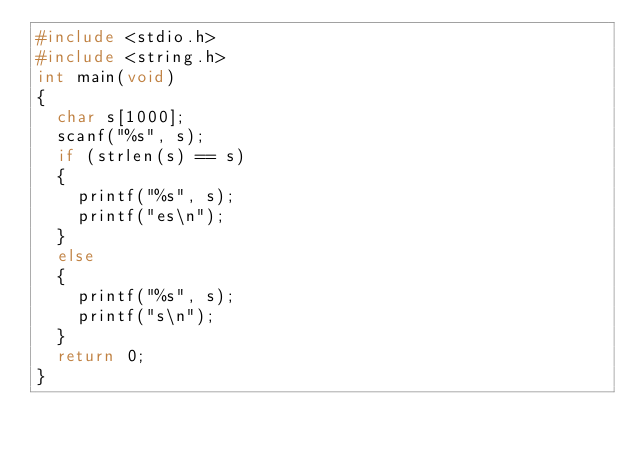Convert code to text. <code><loc_0><loc_0><loc_500><loc_500><_C_>#include <stdio.h>
#include <string.h>
int main(void)
{
  char s[1000];
  scanf("%s", s);
  if (strlen(s) == s)
  {
    printf("%s", s);
    printf("es\n");
  }
  else
  {
    printf("%s", s);
    printf("s\n");
  }
  return 0;
}
</code> 